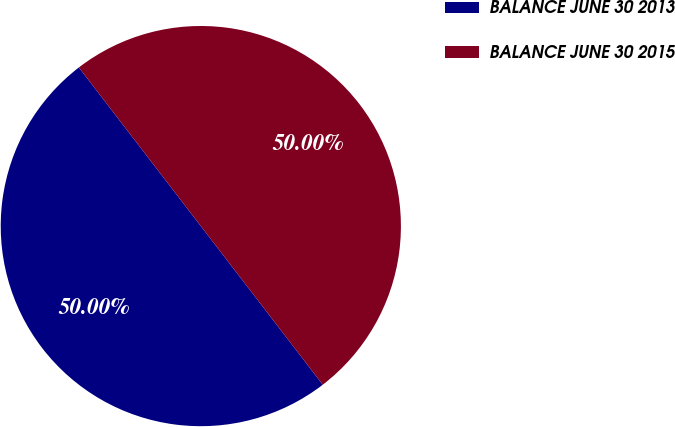Convert chart to OTSL. <chart><loc_0><loc_0><loc_500><loc_500><pie_chart><fcel>BALANCE JUNE 30 2013<fcel>BALANCE JUNE 30 2015<nl><fcel>50.0%<fcel>50.0%<nl></chart> 